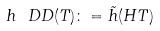<formula> <loc_0><loc_0><loc_500><loc_500>h _ { \ } D D ( T ) \colon = \tilde { h } ( H T )</formula> 